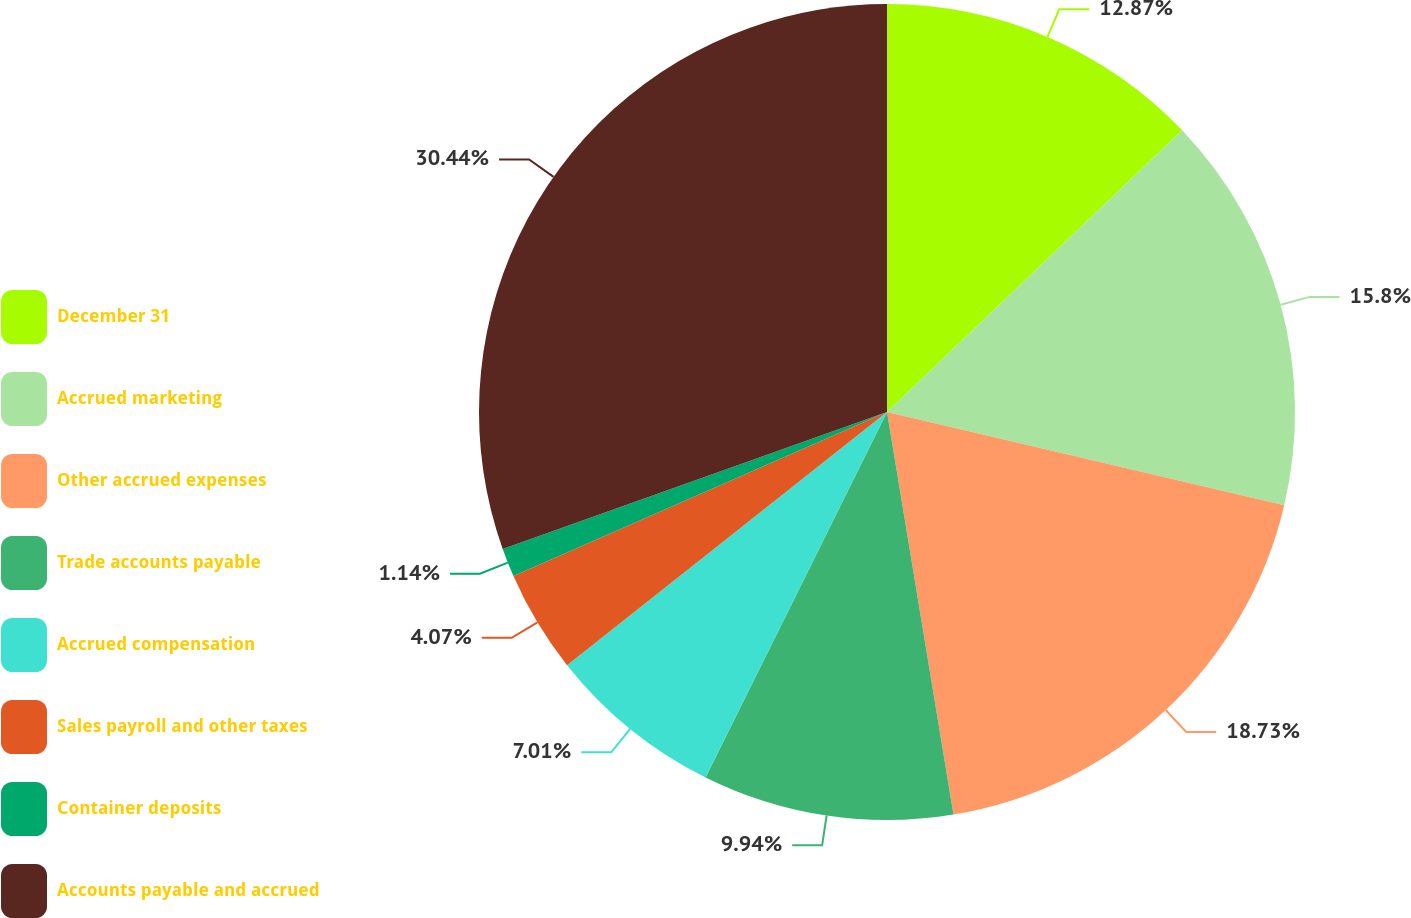<chart> <loc_0><loc_0><loc_500><loc_500><pie_chart><fcel>December 31<fcel>Accrued marketing<fcel>Other accrued expenses<fcel>Trade accounts payable<fcel>Accrued compensation<fcel>Sales payroll and other taxes<fcel>Container deposits<fcel>Accounts payable and accrued<nl><fcel>12.87%<fcel>15.8%<fcel>18.73%<fcel>9.94%<fcel>7.01%<fcel>4.07%<fcel>1.14%<fcel>30.45%<nl></chart> 